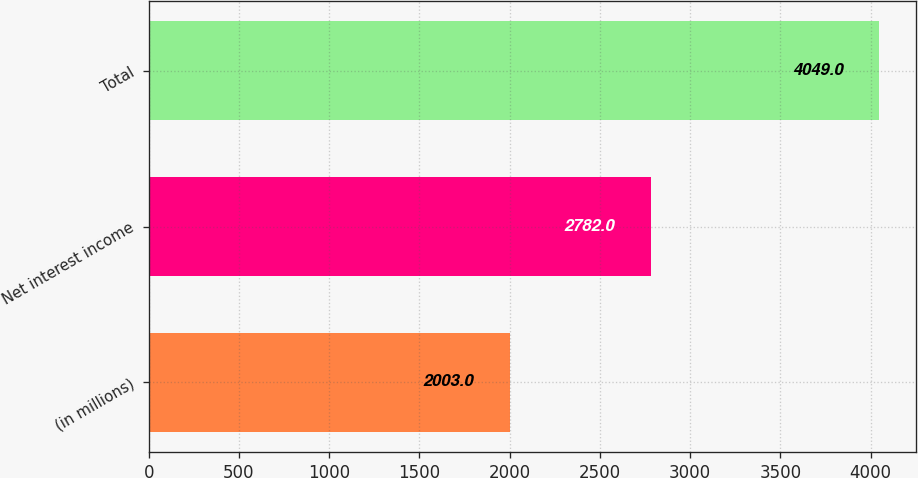<chart> <loc_0><loc_0><loc_500><loc_500><bar_chart><fcel>(in millions)<fcel>Net interest income<fcel>Total<nl><fcel>2003<fcel>2782<fcel>4049<nl></chart> 